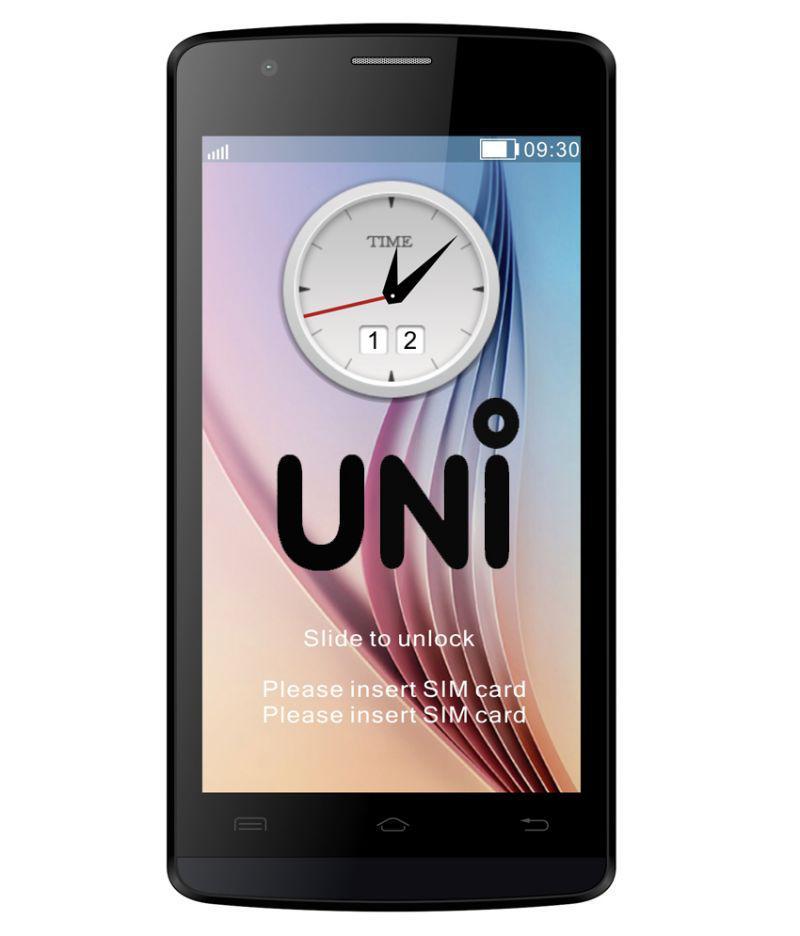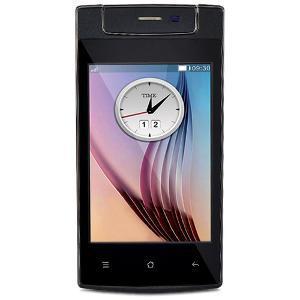The first image is the image on the left, the second image is the image on the right. For the images shown, is this caption "Twenty one or more physical buttons are visible." true? Answer yes or no. No. The first image is the image on the left, the second image is the image on the right. For the images displayed, is the sentence "The left image shows a side-view of a white phone on the left of a back view of a white phone." factually correct? Answer yes or no. No. 